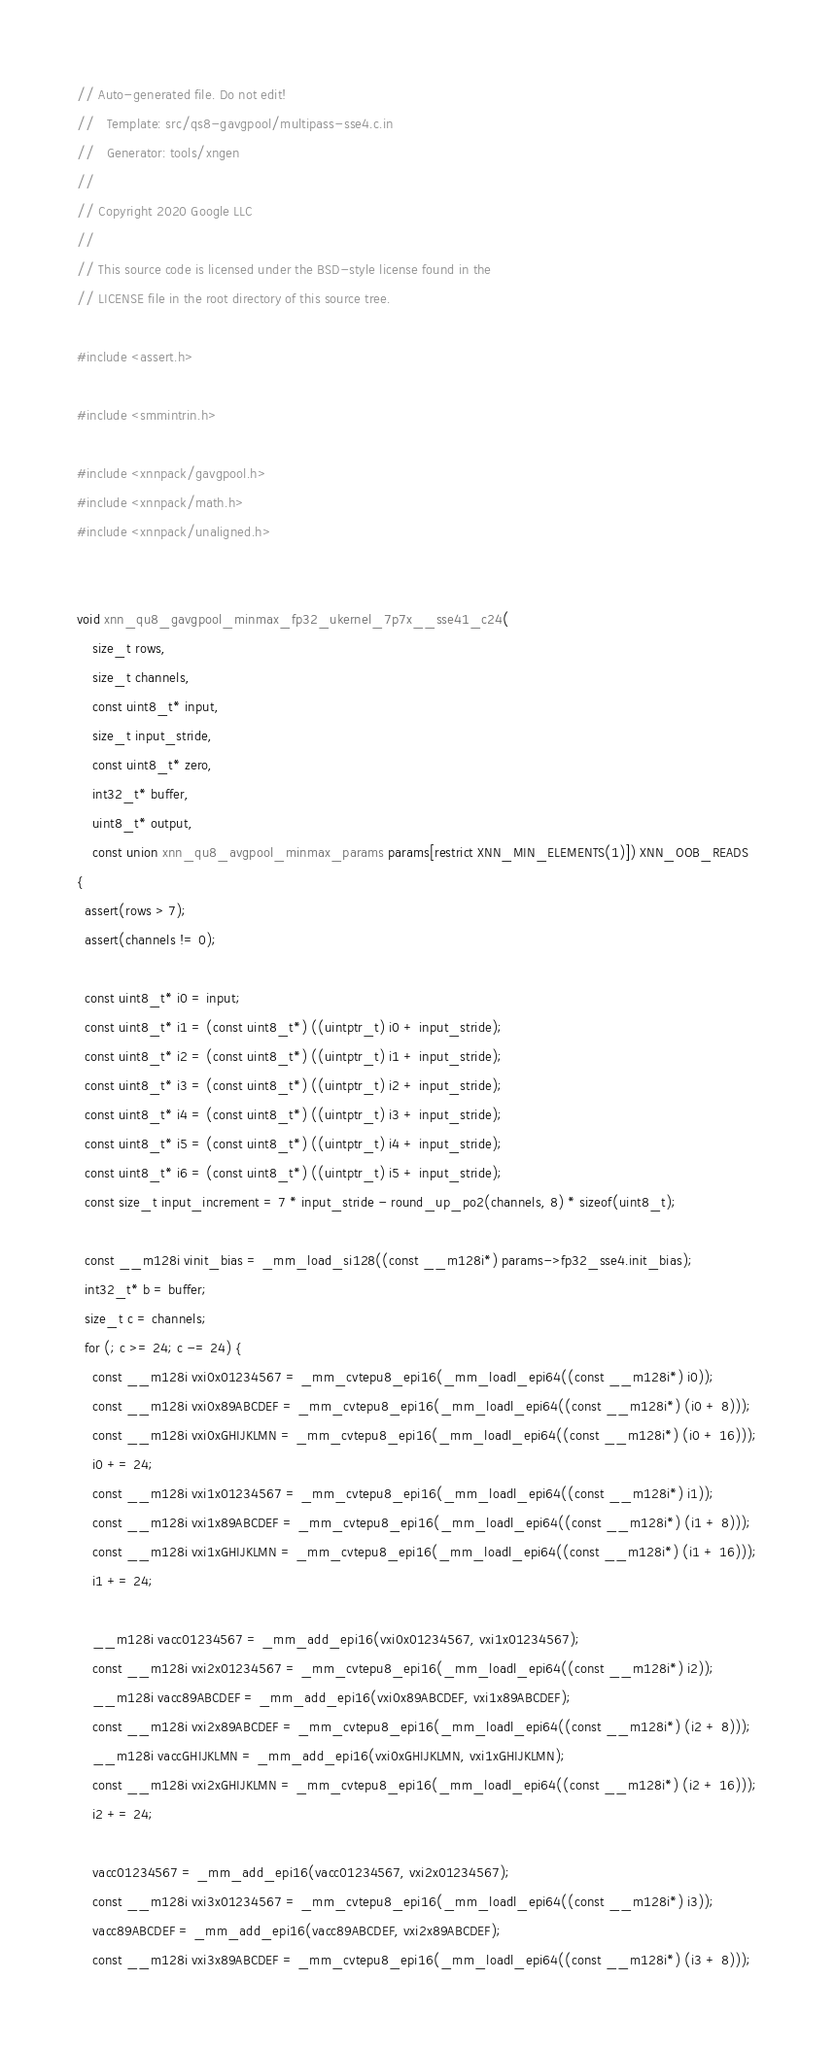Convert code to text. <code><loc_0><loc_0><loc_500><loc_500><_C_>// Auto-generated file. Do not edit!
//   Template: src/qs8-gavgpool/multipass-sse4.c.in
//   Generator: tools/xngen
//
// Copyright 2020 Google LLC
//
// This source code is licensed under the BSD-style license found in the
// LICENSE file in the root directory of this source tree.

#include <assert.h>

#include <smmintrin.h>

#include <xnnpack/gavgpool.h>
#include <xnnpack/math.h>
#include <xnnpack/unaligned.h>


void xnn_qu8_gavgpool_minmax_fp32_ukernel_7p7x__sse41_c24(
    size_t rows,
    size_t channels,
    const uint8_t* input,
    size_t input_stride,
    const uint8_t* zero,
    int32_t* buffer,
    uint8_t* output,
    const union xnn_qu8_avgpool_minmax_params params[restrict XNN_MIN_ELEMENTS(1)]) XNN_OOB_READS
{
  assert(rows > 7);
  assert(channels != 0);

  const uint8_t* i0 = input;
  const uint8_t* i1 = (const uint8_t*) ((uintptr_t) i0 + input_stride);
  const uint8_t* i2 = (const uint8_t*) ((uintptr_t) i1 + input_stride);
  const uint8_t* i3 = (const uint8_t*) ((uintptr_t) i2 + input_stride);
  const uint8_t* i4 = (const uint8_t*) ((uintptr_t) i3 + input_stride);
  const uint8_t* i5 = (const uint8_t*) ((uintptr_t) i4 + input_stride);
  const uint8_t* i6 = (const uint8_t*) ((uintptr_t) i5 + input_stride);
  const size_t input_increment = 7 * input_stride - round_up_po2(channels, 8) * sizeof(uint8_t);

  const __m128i vinit_bias = _mm_load_si128((const __m128i*) params->fp32_sse4.init_bias);
  int32_t* b = buffer;
  size_t c = channels;
  for (; c >= 24; c -= 24) {
    const __m128i vxi0x01234567 = _mm_cvtepu8_epi16(_mm_loadl_epi64((const __m128i*) i0));
    const __m128i vxi0x89ABCDEF = _mm_cvtepu8_epi16(_mm_loadl_epi64((const __m128i*) (i0 + 8)));
    const __m128i vxi0xGHIJKLMN = _mm_cvtepu8_epi16(_mm_loadl_epi64((const __m128i*) (i0 + 16)));
    i0 += 24;
    const __m128i vxi1x01234567 = _mm_cvtepu8_epi16(_mm_loadl_epi64((const __m128i*) i1));
    const __m128i vxi1x89ABCDEF = _mm_cvtepu8_epi16(_mm_loadl_epi64((const __m128i*) (i1 + 8)));
    const __m128i vxi1xGHIJKLMN = _mm_cvtepu8_epi16(_mm_loadl_epi64((const __m128i*) (i1 + 16)));
    i1 += 24;

    __m128i vacc01234567 = _mm_add_epi16(vxi0x01234567, vxi1x01234567);
    const __m128i vxi2x01234567 = _mm_cvtepu8_epi16(_mm_loadl_epi64((const __m128i*) i2));
    __m128i vacc89ABCDEF = _mm_add_epi16(vxi0x89ABCDEF, vxi1x89ABCDEF);
    const __m128i vxi2x89ABCDEF = _mm_cvtepu8_epi16(_mm_loadl_epi64((const __m128i*) (i2 + 8)));
    __m128i vaccGHIJKLMN = _mm_add_epi16(vxi0xGHIJKLMN, vxi1xGHIJKLMN);
    const __m128i vxi2xGHIJKLMN = _mm_cvtepu8_epi16(_mm_loadl_epi64((const __m128i*) (i2 + 16)));
    i2 += 24;

    vacc01234567 = _mm_add_epi16(vacc01234567, vxi2x01234567);
    const __m128i vxi3x01234567 = _mm_cvtepu8_epi16(_mm_loadl_epi64((const __m128i*) i3));
    vacc89ABCDEF = _mm_add_epi16(vacc89ABCDEF, vxi2x89ABCDEF);
    const __m128i vxi3x89ABCDEF = _mm_cvtepu8_epi16(_mm_loadl_epi64((const __m128i*) (i3 + 8)));</code> 